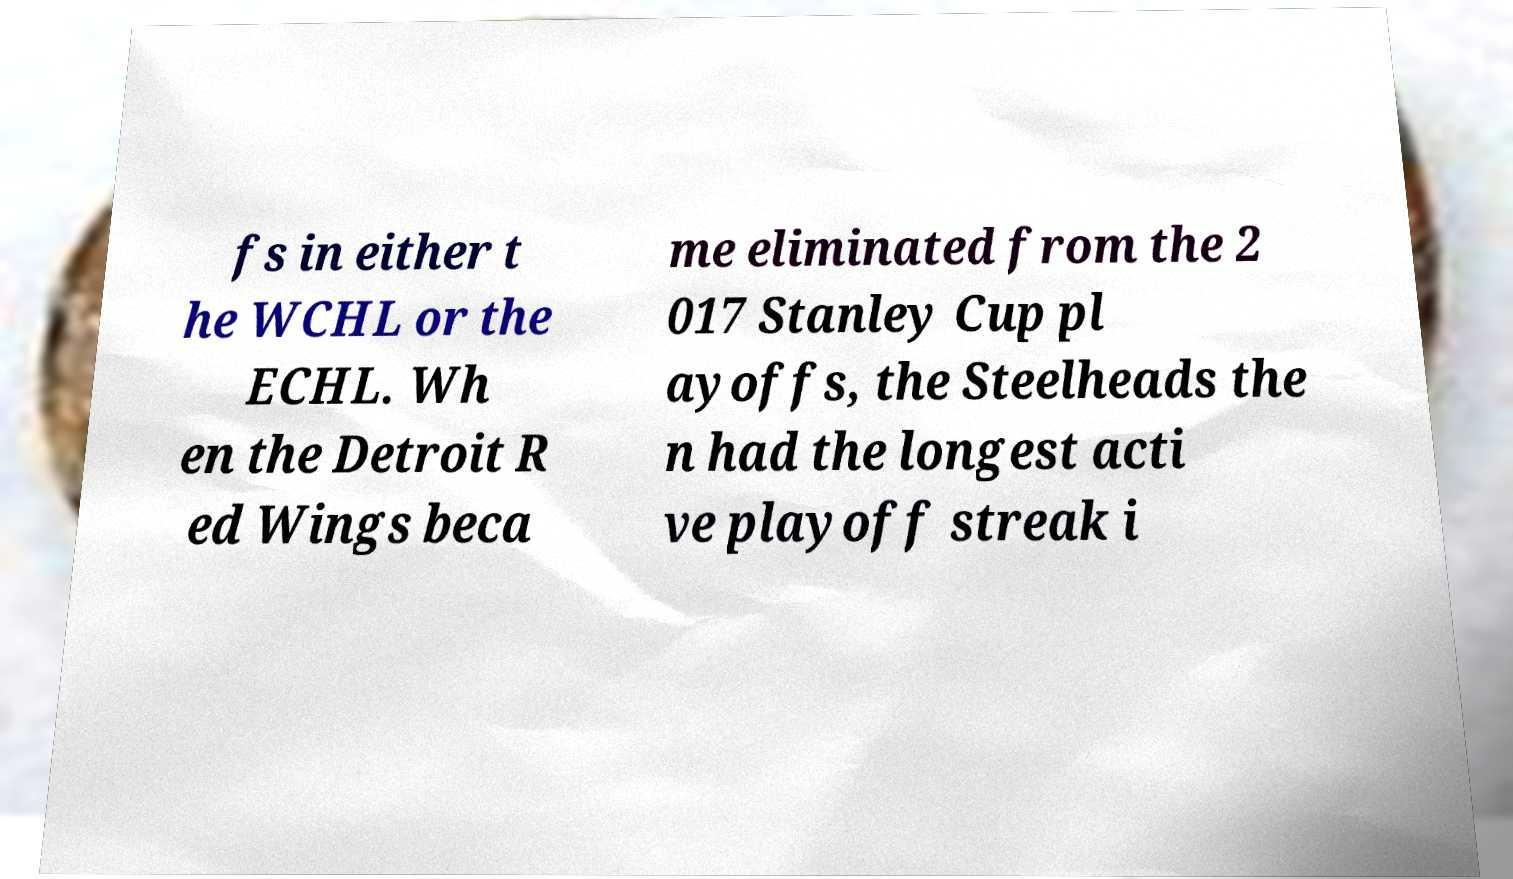Please identify and transcribe the text found in this image. fs in either t he WCHL or the ECHL. Wh en the Detroit R ed Wings beca me eliminated from the 2 017 Stanley Cup pl ayoffs, the Steelheads the n had the longest acti ve playoff streak i 